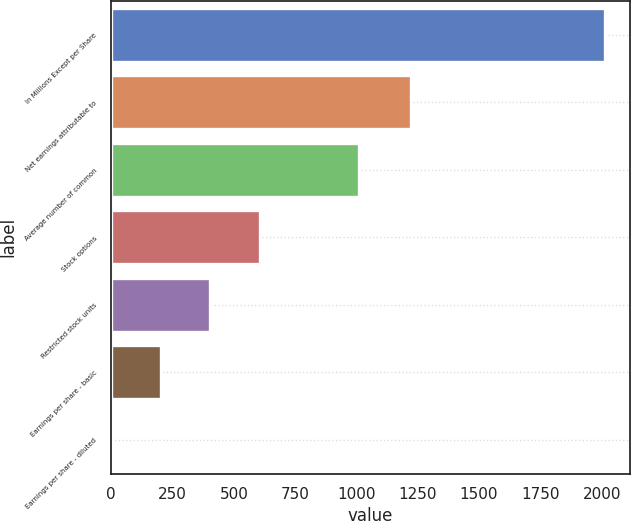<chart> <loc_0><loc_0><loc_500><loc_500><bar_chart><fcel>In Millions Except per Share<fcel>Net earnings attributable to<fcel>Average number of common<fcel>Stock options<fcel>Restricted stock units<fcel>Earnings per share - basic<fcel>Earnings per share - diluted<nl><fcel>2015<fcel>1221.3<fcel>1008.47<fcel>605.87<fcel>404.57<fcel>203.27<fcel>1.97<nl></chart> 